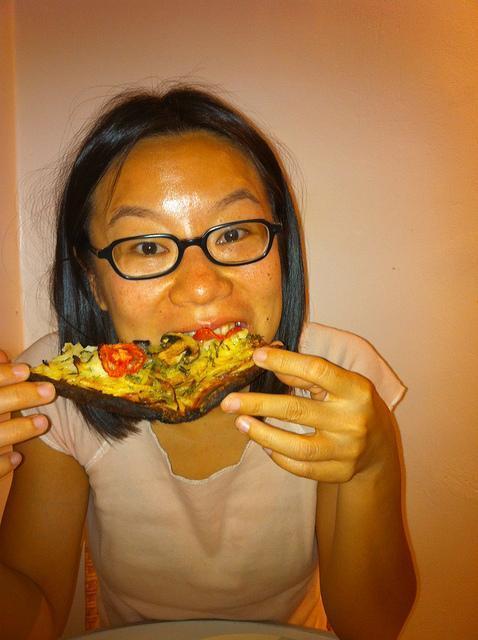How many bicycles are pictured?
Give a very brief answer. 0. 